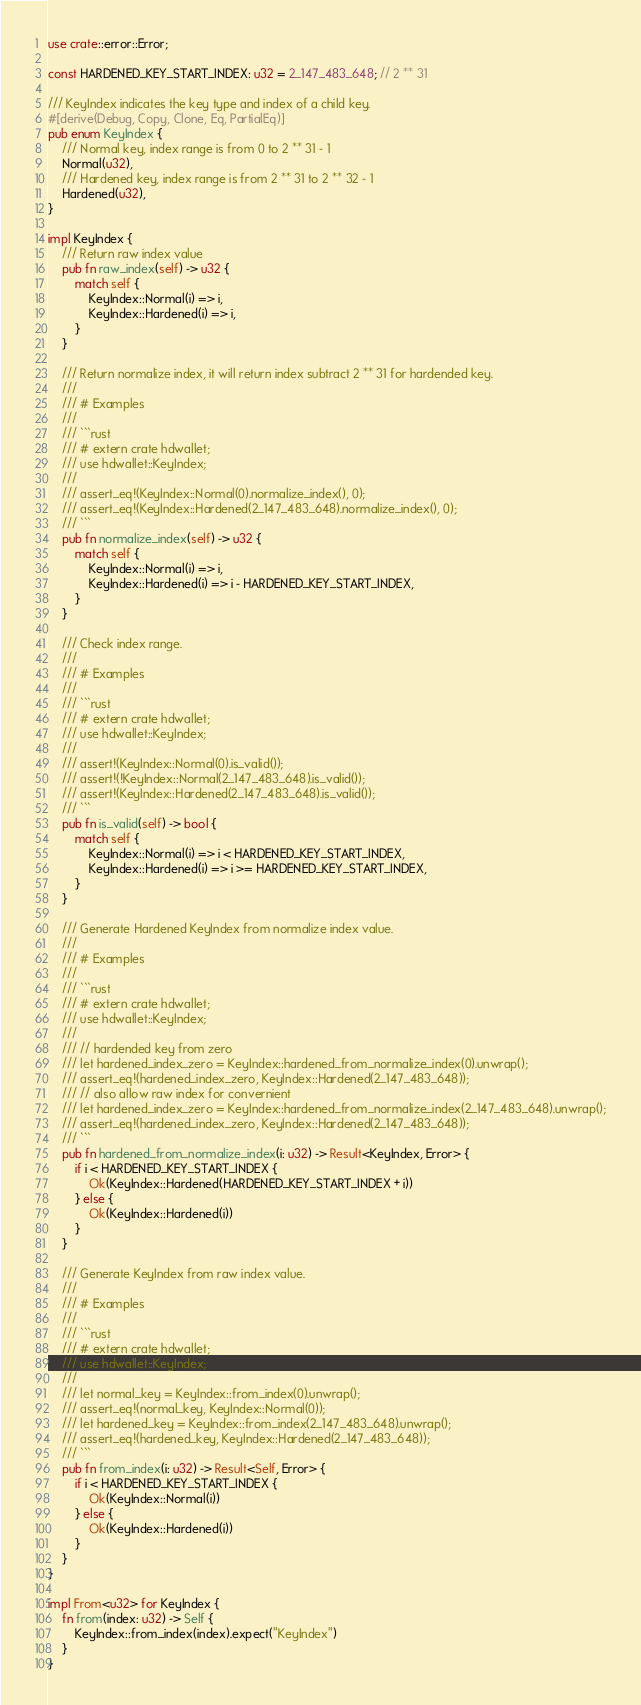Convert code to text. <code><loc_0><loc_0><loc_500><loc_500><_Rust_>use crate::error::Error;

const HARDENED_KEY_START_INDEX: u32 = 2_147_483_648; // 2 ** 31

/// KeyIndex indicates the key type and index of a child key.
#[derive(Debug, Copy, Clone, Eq, PartialEq)]
pub enum KeyIndex {
    /// Normal key, index range is from 0 to 2 ** 31 - 1
    Normal(u32),
    /// Hardened key, index range is from 2 ** 31 to 2 ** 32 - 1
    Hardened(u32),
}

impl KeyIndex {
    /// Return raw index value
    pub fn raw_index(self) -> u32 {
        match self {
            KeyIndex::Normal(i) => i,
            KeyIndex::Hardened(i) => i,
        }
    }

    /// Return normalize index, it will return index subtract 2 ** 31 for hardended key.
    ///
    /// # Examples
    ///
    /// ```rust
    /// # extern crate hdwallet;
    /// use hdwallet::KeyIndex;
    ///
    /// assert_eq!(KeyIndex::Normal(0).normalize_index(), 0);
    /// assert_eq!(KeyIndex::Hardened(2_147_483_648).normalize_index(), 0);
    /// ```
    pub fn normalize_index(self) -> u32 {
        match self {
            KeyIndex::Normal(i) => i,
            KeyIndex::Hardened(i) => i - HARDENED_KEY_START_INDEX,
        }
    }

    /// Check index range.
    ///
    /// # Examples
    ///
    /// ```rust
    /// # extern crate hdwallet;
    /// use hdwallet::KeyIndex;
    ///
    /// assert!(KeyIndex::Normal(0).is_valid());
    /// assert!(!KeyIndex::Normal(2_147_483_648).is_valid());
    /// assert!(KeyIndex::Hardened(2_147_483_648).is_valid());
    /// ```
    pub fn is_valid(self) -> bool {
        match self {
            KeyIndex::Normal(i) => i < HARDENED_KEY_START_INDEX,
            KeyIndex::Hardened(i) => i >= HARDENED_KEY_START_INDEX,
        }
    }

    /// Generate Hardened KeyIndex from normalize index value.
    ///
    /// # Examples
    ///
    /// ```rust
    /// # extern crate hdwallet;
    /// use hdwallet::KeyIndex;
    ///
    /// // hardended key from zero
    /// let hardened_index_zero = KeyIndex::hardened_from_normalize_index(0).unwrap();
    /// assert_eq!(hardened_index_zero, KeyIndex::Hardened(2_147_483_648));
    /// // also allow raw index for convernient
    /// let hardened_index_zero = KeyIndex::hardened_from_normalize_index(2_147_483_648).unwrap();
    /// assert_eq!(hardened_index_zero, KeyIndex::Hardened(2_147_483_648));
    /// ```
    pub fn hardened_from_normalize_index(i: u32) -> Result<KeyIndex, Error> {
        if i < HARDENED_KEY_START_INDEX {
            Ok(KeyIndex::Hardened(HARDENED_KEY_START_INDEX + i))
        } else {
            Ok(KeyIndex::Hardened(i))
        }
    }

    /// Generate KeyIndex from raw index value.
    ///
    /// # Examples
    ///
    /// ```rust
    /// # extern crate hdwallet;
    /// use hdwallet::KeyIndex;
    ///
    /// let normal_key = KeyIndex::from_index(0).unwrap();
    /// assert_eq!(normal_key, KeyIndex::Normal(0));
    /// let hardened_key = KeyIndex::from_index(2_147_483_648).unwrap();
    /// assert_eq!(hardened_key, KeyIndex::Hardened(2_147_483_648));
    /// ```
    pub fn from_index(i: u32) -> Result<Self, Error> {
        if i < HARDENED_KEY_START_INDEX {
            Ok(KeyIndex::Normal(i))
        } else {
            Ok(KeyIndex::Hardened(i))
        }
    }
}

impl From<u32> for KeyIndex {
    fn from(index: u32) -> Self {
        KeyIndex::from_index(index).expect("KeyIndex")
    }
}
</code> 